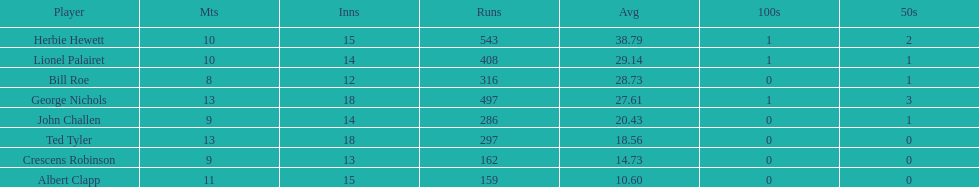Can you mention a player who had an average greater than 25? Herbie Hewett. Parse the full table. {'header': ['Player', 'Mts', 'Inns', 'Runs', 'Avg', '100s', '50s'], 'rows': [['Herbie Hewett', '10', '15', '543', '38.79', '1', '2'], ['Lionel Palairet', '10', '14', '408', '29.14', '1', '1'], ['Bill Roe', '8', '12', '316', '28.73', '0', '1'], ['George Nichols', '13', '18', '497', '27.61', '1', '3'], ['John Challen', '9', '14', '286', '20.43', '0', '1'], ['Ted Tyler', '13', '18', '297', '18.56', '0', '0'], ['Crescens Robinson', '9', '13', '162', '14.73', '0', '0'], ['Albert Clapp', '11', '15', '159', '10.60', '0', '0']]} 